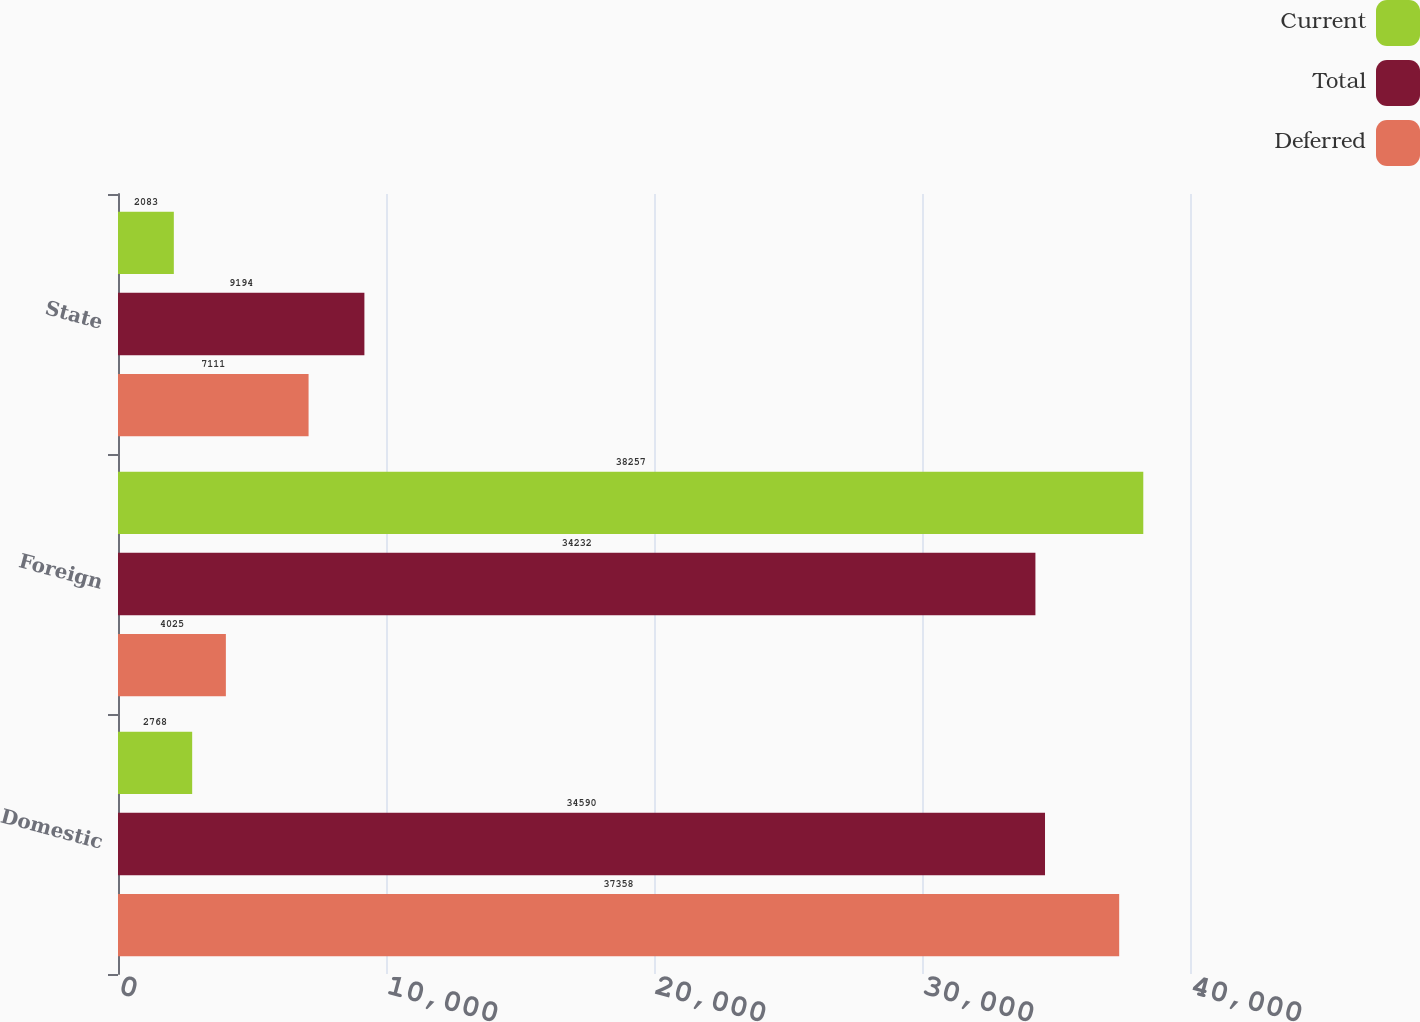Convert chart. <chart><loc_0><loc_0><loc_500><loc_500><stacked_bar_chart><ecel><fcel>Domestic<fcel>Foreign<fcel>State<nl><fcel>Current<fcel>2768<fcel>38257<fcel>2083<nl><fcel>Total<fcel>34590<fcel>34232<fcel>9194<nl><fcel>Deferred<fcel>37358<fcel>4025<fcel>7111<nl></chart> 